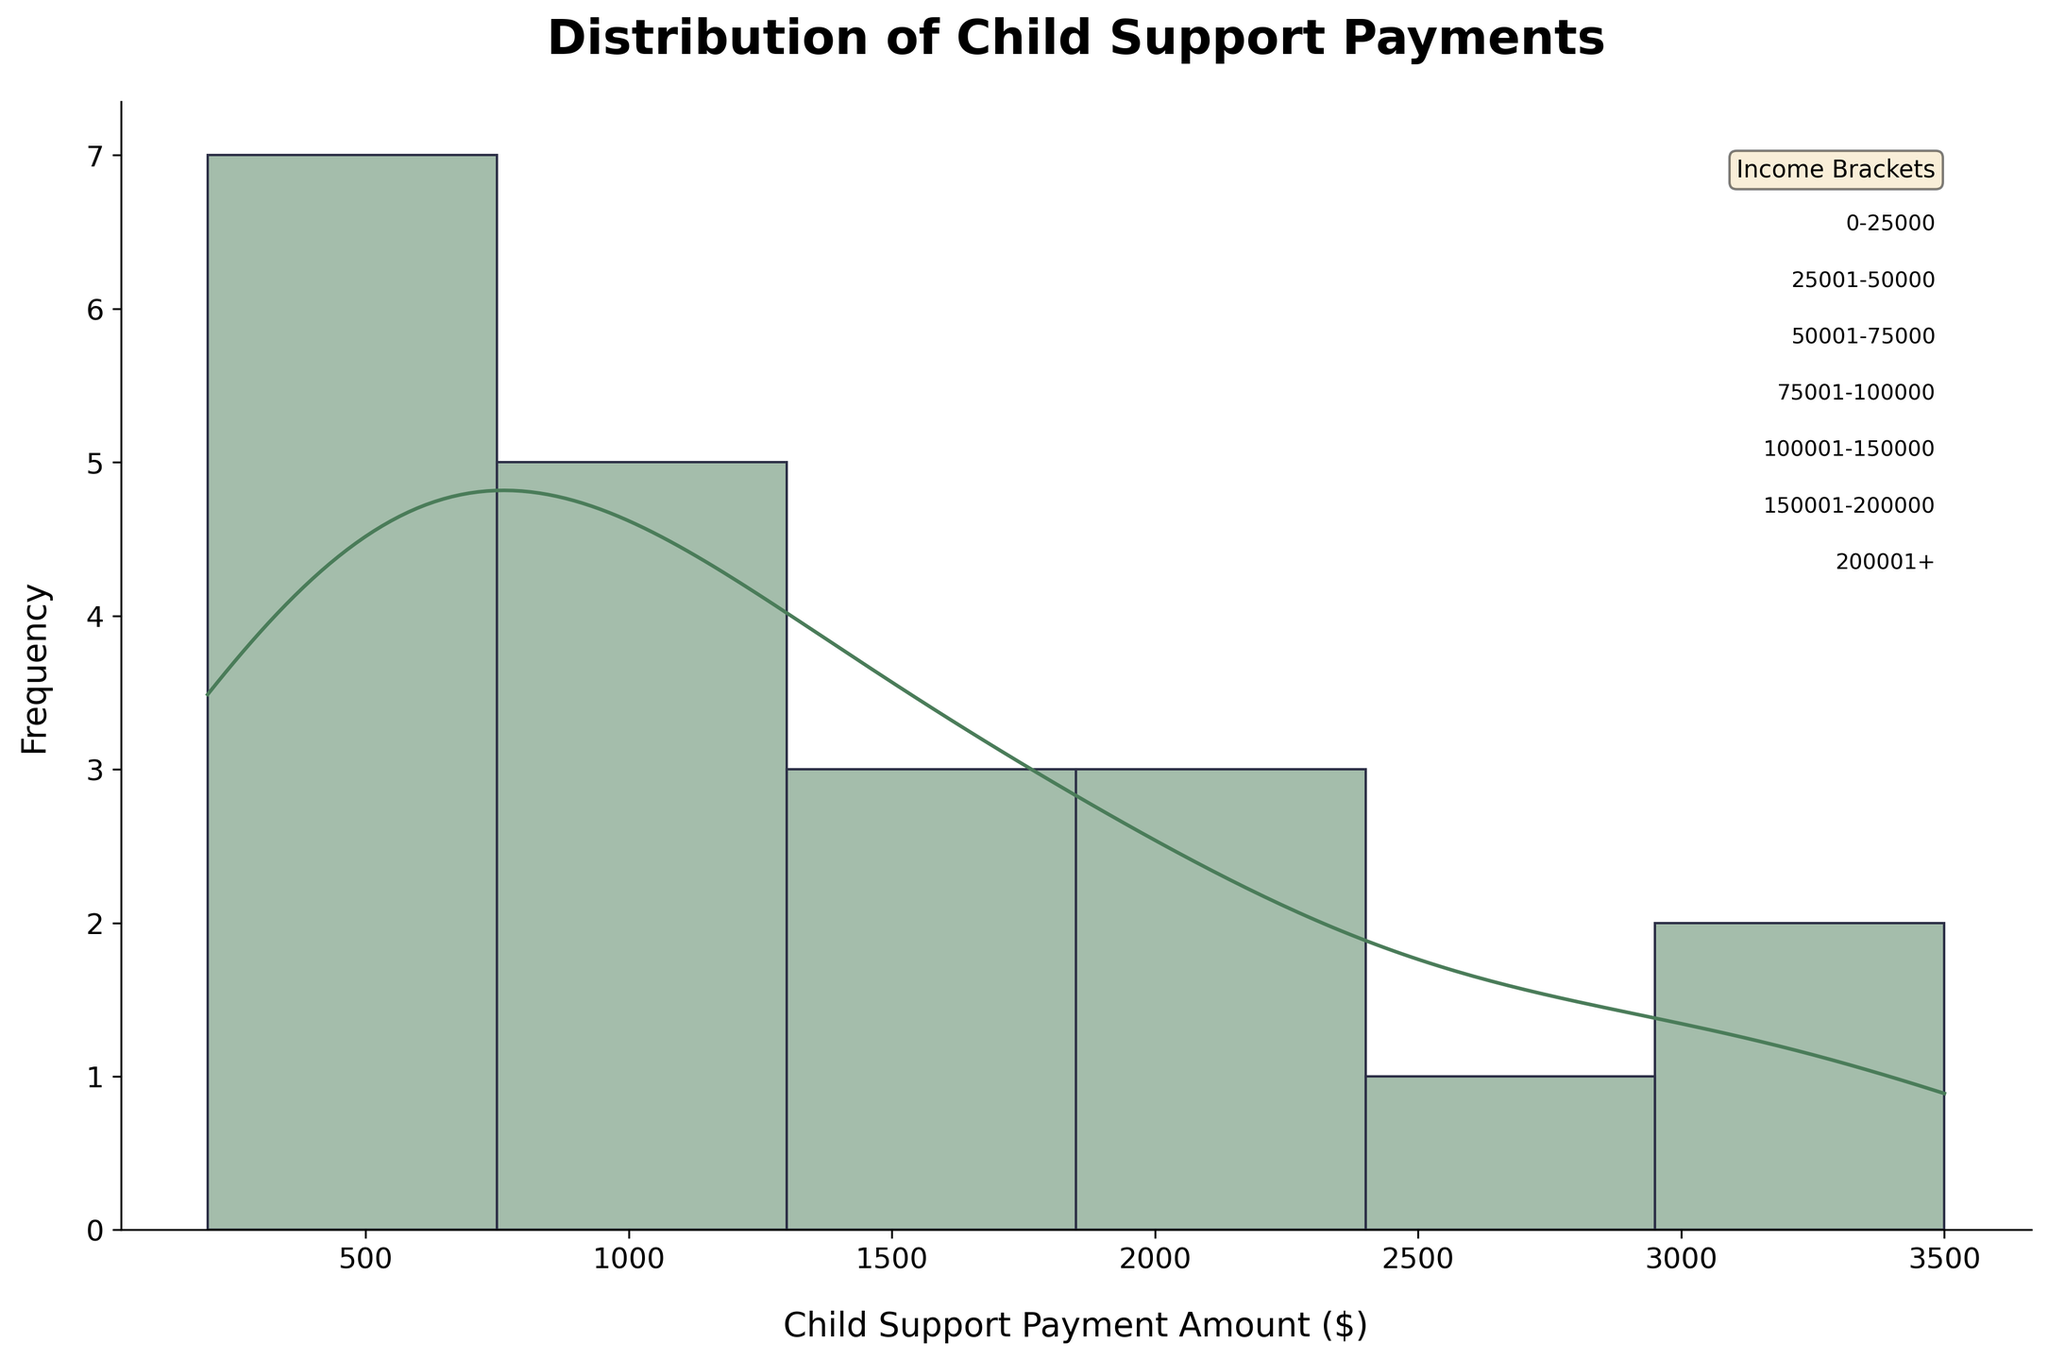What is the title of the figure? The title is displayed at the top of the figure in bold font.
Answer: Distribution of Child Support Payments What do the x and y axes represent? The labels on the x and y axes indicate what they measure. The x-axis represents "Child Support Payment Amount ($)," and the y-axis represents "Frequency."
Answer: The x-axis represents "Child Support Payment Amount ($)" and the y-axis represents "Frequency." What's the color of the KDE (density) curve? The KDE curve color can be observed directly on the figure.
Answer: Orange Which income bracket has the highest child support payments? There is a label indicating each income bracket, and the highest child support payments can be observed from the figures where the KDE curve peaks.
Answer: 200001+ What is the estimated peak of the KDE curve in the income bracket 50001-75000? You need to look at the KDE curve's peak value on the x-axis for the income bracket 50001-75000, which are specified in the KDE section of the figure.
Answer: Approximately $750 Which income bracket has the widest range of child support payments? Observing the spread of data points along the x-axis will show which income bracket has the widest distribution. The income bracket 200001+ shows payments from approximately $2800 to $3500, which is the widest range.
Answer: 200001+ How do the child support payments for the lowest income bracket (0-25000) compare with those for the highest income bracket (200001+)? By comparing the x-axis ranges and KDE curve peaks for the lowest and highest income brackets, you can see that the lowest income bracket ranges between $200 and $300, while the highest ranges between $2800 and $3500.
Answer: The highest income bracket has much higher child support payments than the lowest income bracket What is the range of child support payments for the income bracket 100001-150000? You need to look at the x-axis values spanned by the KDE curve for the 100001-150000 income bracket.
Answer: $1400 to $1600 What can you infer about the concentration of child support payments in the income bracket 75001-100000? By observing the density of the histogram and the peak of the KDE curve, you can infer that payments are concentrated around $1000-$1100.
Answer: They are concentrated around $1000-$1100 What is the difference in the peak values of the KDE curve between income brackets 25001-50000 and 150001-200000? Find the peak KDE curve values for both brackets and then calculate the difference. The peak for 25001-50000 is approximately $500, and for 150001-200000 is approximately $2000. The difference is $2000 - $500 = $1500.
Answer: $1500 